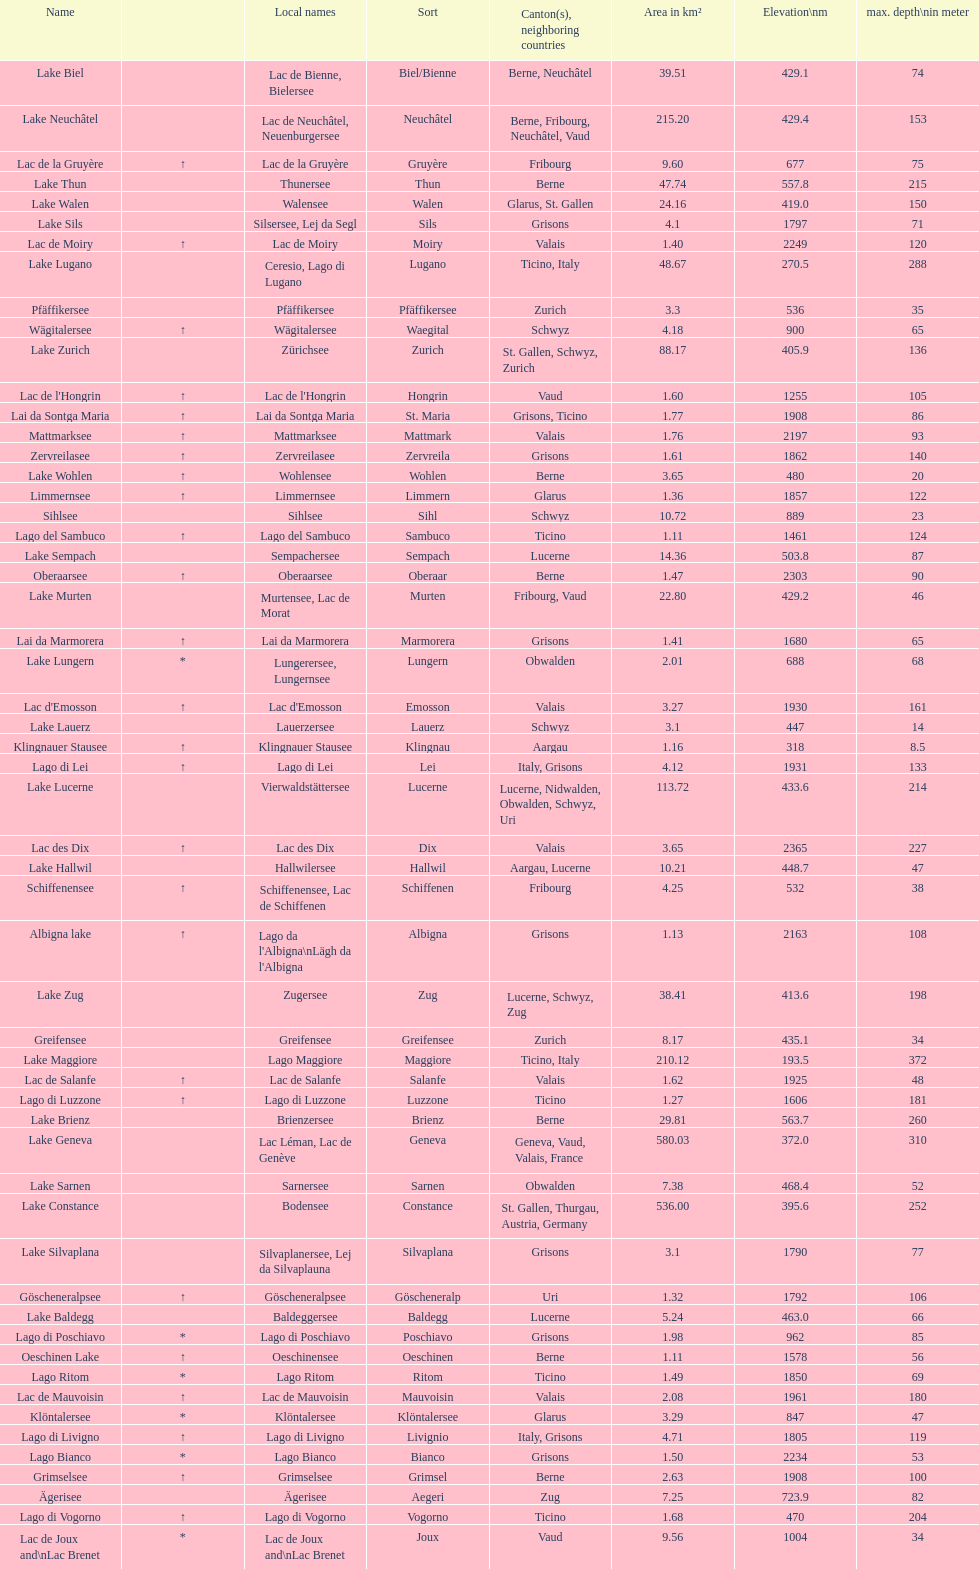What is the combined total depth of the three deepest lakes? 970. 